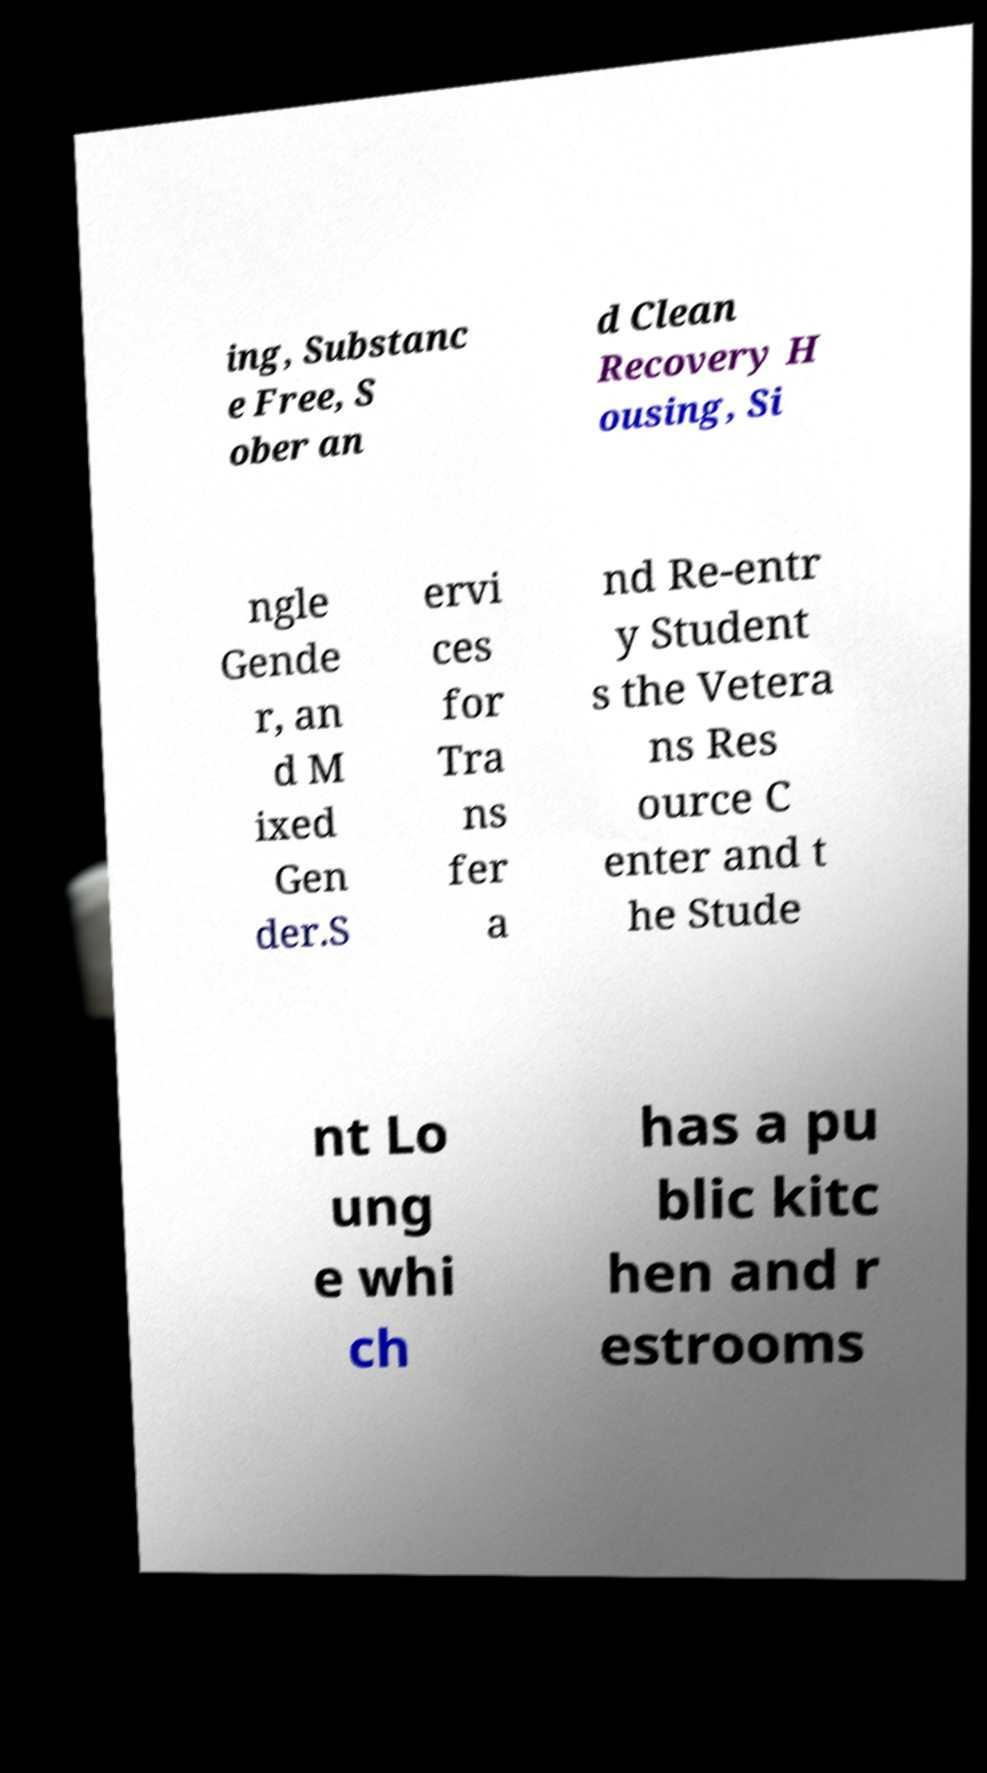Could you extract and type out the text from this image? ing, Substanc e Free, S ober an d Clean Recovery H ousing, Si ngle Gende r, an d M ixed Gen der.S ervi ces for Tra ns fer a nd Re-entr y Student s the Vetera ns Res ource C enter and t he Stude nt Lo ung e whi ch has a pu blic kitc hen and r estrooms 